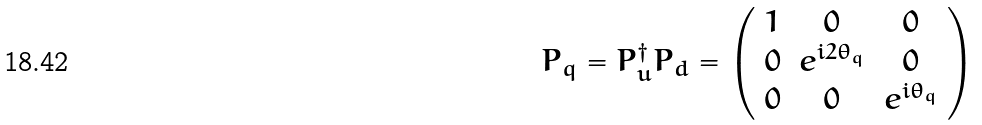Convert formula to latex. <formula><loc_0><loc_0><loc_500><loc_500>P _ { q } = P _ { u } ^ { \dag } P _ { d } = \left ( \begin{array} { c c c } 1 & 0 & 0 \\ 0 & e ^ { i 2 \theta _ { q } } & 0 \\ 0 & 0 & e ^ { i \theta _ { q } } \end{array} \right )</formula> 